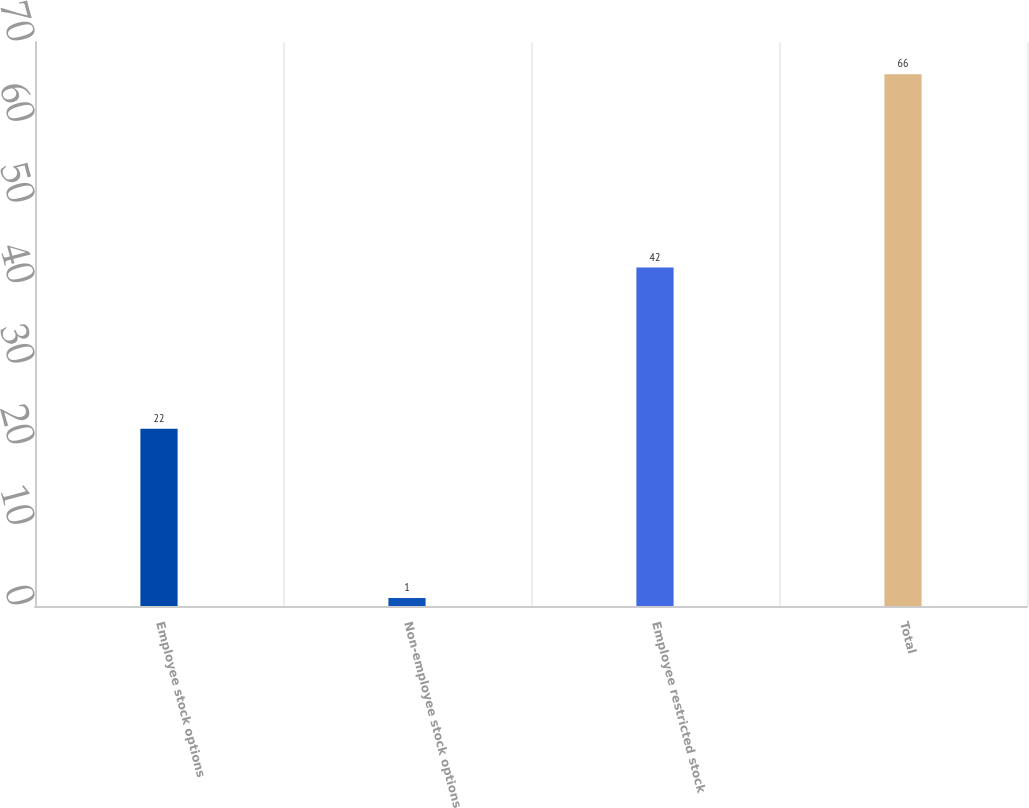<chart> <loc_0><loc_0><loc_500><loc_500><bar_chart><fcel>Employee stock options<fcel>Non-employee stock options<fcel>Employee restricted stock<fcel>Total<nl><fcel>22<fcel>1<fcel>42<fcel>66<nl></chart> 